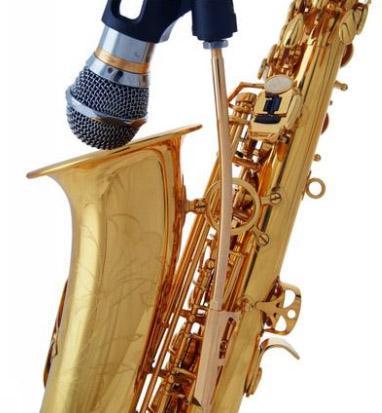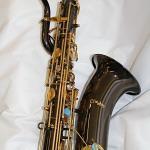The first image is the image on the left, the second image is the image on the right. Analyze the images presented: Is the assertion "The entire instrument is visible in every image." valid? Answer yes or no. No. 